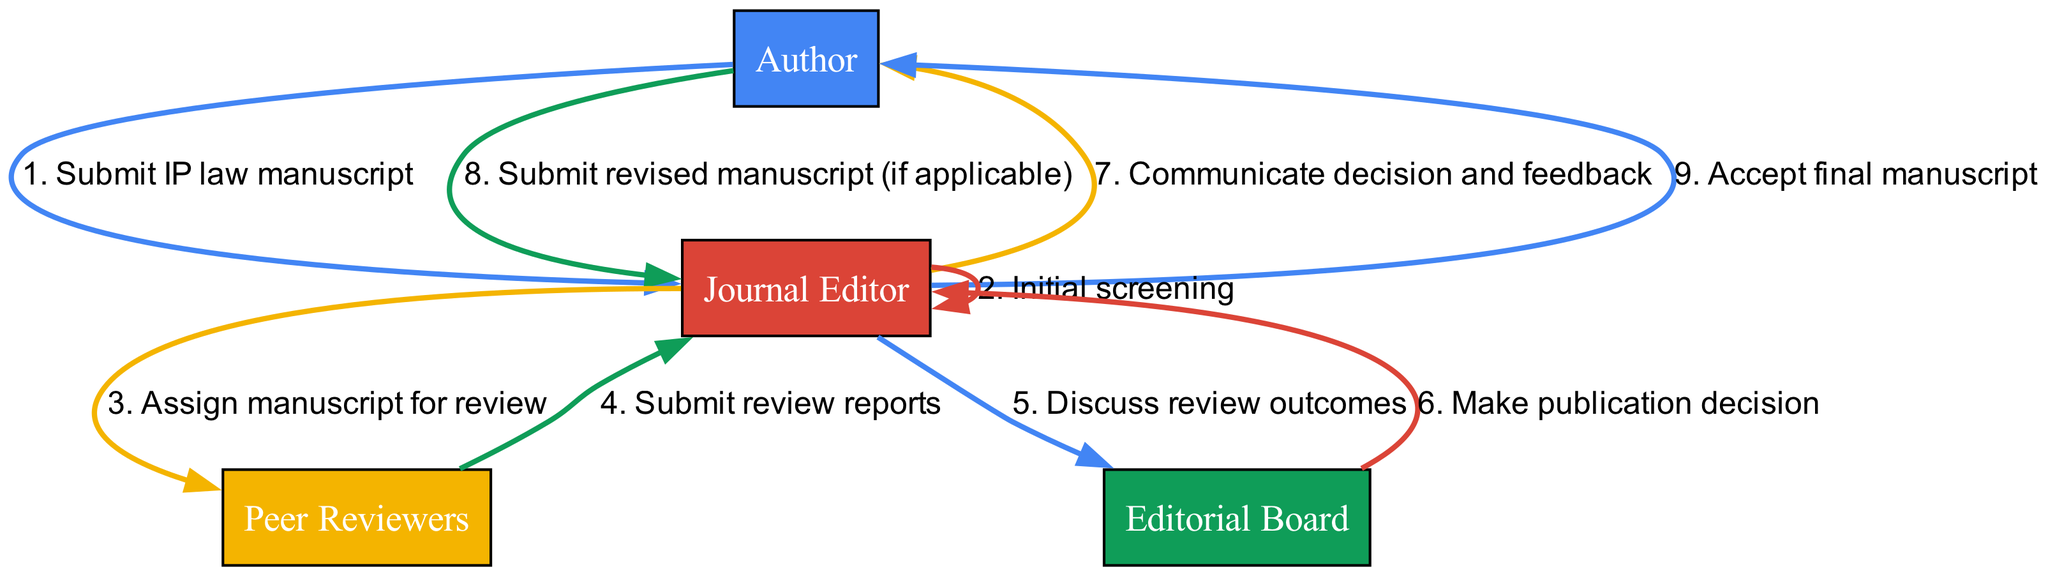What is the first action taken in the process? The first action is initiated by the Author, who submits the IP law manuscript to the Journal Editor. This is indicated as the first interaction in the sequence diagram.
Answer: Submit IP law manuscript How many peer reviewers are involved in the process? The diagram does not specify a number of peer reviewers, but it indicates that the Journal Editor assigns the manuscript for review to Peer Reviewers, suggesting there could be one or more involved.
Answer: Unknown What is the second action in the sequence? The second action occurs when the Journal Editor conducts an initial screening of the submitted manuscript. This is the second interaction in the diagram's sequence.
Answer: Initial screening What does the Editorial Board do after discussing review outcomes? After discussing review outcomes, the Editorial Board makes a publication decision, which is a key step in the process following their discussion. This is represented in the diagram as the next action after their deliberation.
Answer: Make publication decision Which actor communicates the decision and feedback to the Author? The Journal Editor is responsible for communicating the decision and feedback to the Author, as specified in the sequence that follows the review and decision-making steps.
Answer: Journal Editor How many total actions are represented in the diagram? By counting the actions as indicated by the sequences, there are a total of eight actions represented in the diagram.
Answer: Eight What happens if the author needs to revise the manuscript? If the author needs to make revisions, they submit a revised manuscript to the Journal Editor, as indicated in the sequence after the feedback is communicated.
Answer: Submit revised manuscript (if applicable) What is the last action in the sequence? The last action in the process is the Journal Editor accepting the final manuscript from the Author, marking the completion of the submission and review process.
Answer: Accept final manuscript 